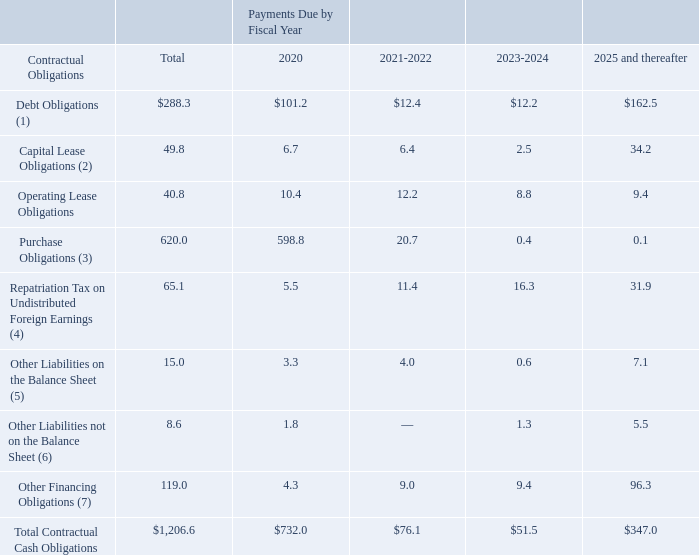CONTRACTUAL OBLIGATIONS, COMMITMENTS AND OFF-BALANCE SHEET OBLIGATIONS
Our disclosures regarding contractual obligations and commercial commitments are located in various parts of our regulatory filings. Information in the following table provides a summary of our contractual obligations and commercial commitments as of September 28, 2019 (dollars in millions):
1) Includes $150.0 million in principal amount of 2018 Notes as well as interest; see Note 4, "Debt, Capital Lease Obligations and Other Financing," in Notes to Consolidated Financial Statements for further information.
2) As of September 28, 2019, capital lease obligations consists of capital lease payments and interest as well as the non-cash financing obligation related to the failed sale-leasebacks in Guadalajara, Mexico; see Note 4, "Debt, Capital Lease Obligations and Other Financing," in Notes to Consolidated Financial Statements for further information.
3) As of September 28, 2019, purchase obligations consist primarily of purchases of inventory and equipment in the ordinary course of business.
4) Consists of U.S. federal income taxes on the deemed repatriation of undistributed foreign earnings due to Tax Reform. Refer to "Liquidity and Capital Resources" above for further detail.
5) As of September 28, 2019, other obligations on the balance sheet included deferred compensation obligations to certain of our former and current executive officers, as well as other key employees, and an asset retirement obligation. We have excluded from the above table the impact of approximately $2.3 million, as of September 28, 2019, related to unrecognized income tax benefits. The Company cannot make reliable estimates of the future cash flows by period related to these obligations.
6) As of September 28, 2019, other obligations not on the balance sheet consist of guarantees and a commitment for salary continuation and certain benefits in the event employment of one executive officer of the Company is terminated without cause. Excluded from the amounts disclosed are certain bonus and incentive compensation amounts, which would be paid on a prorated basis in the year of termination.
7) Includes future minimum lease payments for two facilities in Guadalajara, Mexico, leased under 10-year and 15-year base lease agreements, both of which include two 5-year renewal options; see Note 4, "Debt, Capital Lease Obligations and Other Financing," in Notes to Consolidated Financial Statements for further information.
What does debt obligations include? $150.0 million in principal amount of 2018 notes as well as interest. What did capital lease obligations consist of as of September 28, 2019? Capital lease payments and interest as well as the non-cash financing obligation related to the failed sale-leasebacks in guadalajara, mexico. What were the total Operating Lease Obligations?
Answer scale should be: million. 40.8. What were the total debt obligations as a percentage of total contractual obligations?
Answer scale should be: percent. 288.3/1,206.6
Answer: 23.89. What was the difference in the total between Other Liabilities on and not on the Balance Sheet?
Answer scale should be: million. 15.0-8.6
Answer: 6.4. What was the difference in the total between  Repatriation Tax on Undistributed Foreign Earnings and Purchase Obligations?
Answer scale should be: million. 620.0-65.1
Answer: 554.9. 